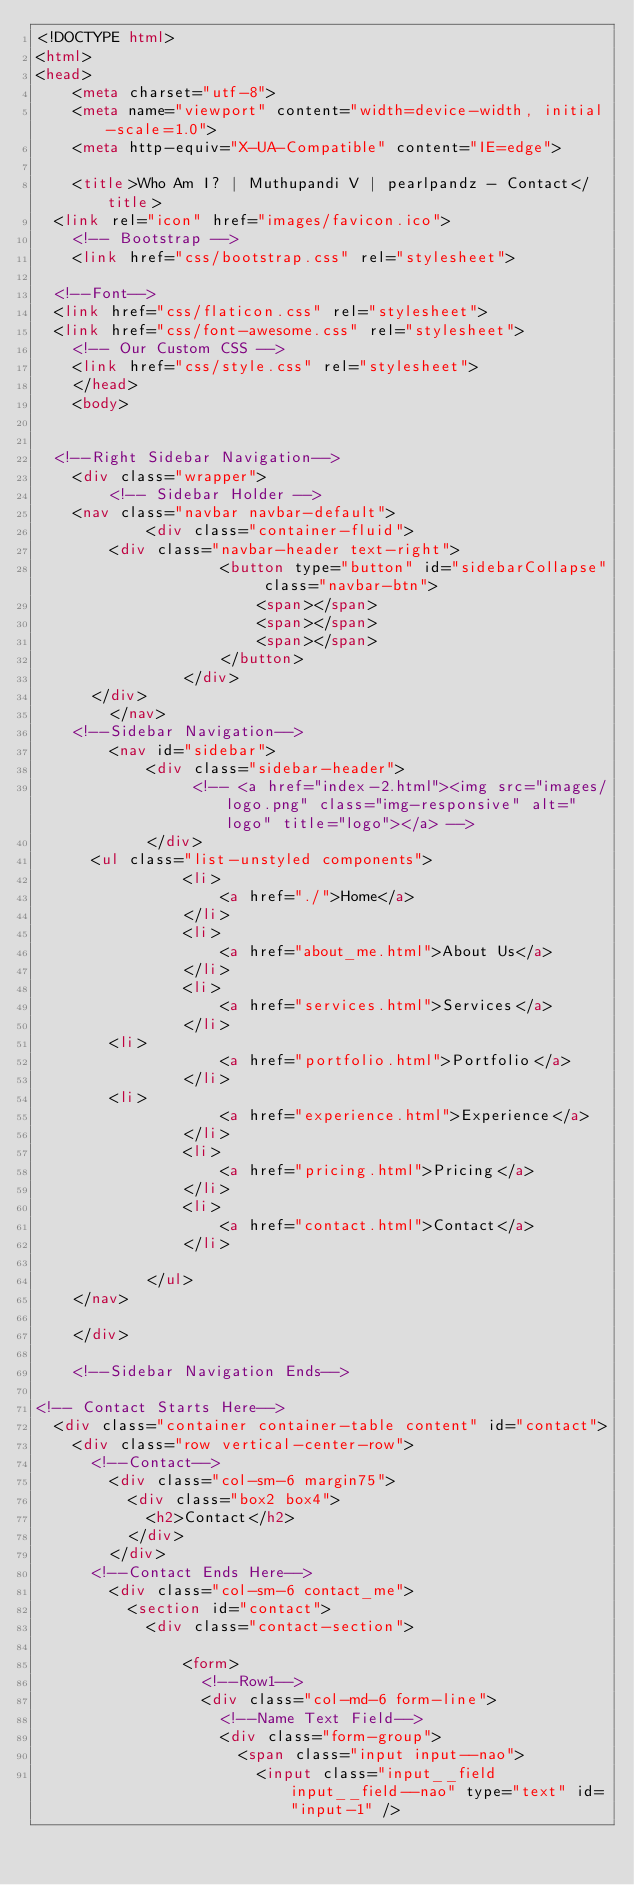<code> <loc_0><loc_0><loc_500><loc_500><_HTML_><!DOCTYPE html>
<html>
<head>
    <meta charset="utf-8">
    <meta name="viewport" content="width=device-width, initial-scale=1.0">
    <meta http-equiv="X-UA-Compatible" content="IE=edge">

    <title>Who Am I? | Muthupandi V | pearlpandz - Contact</title>
	<link rel="icon" href="images/favicon.ico">
    <!-- Bootstrap -->
    <link href="css/bootstrap.css" rel="stylesheet">
	
	<!--Font-->
	<link href="css/flaticon.css" rel="stylesheet">
	<link href="css/font-awesome.css" rel="stylesheet">
    <!-- Our Custom CSS -->
    <link href="css/style.css" rel="stylesheet">
    </head>
    <body>


	<!--Right Sidebar Navigation-->
    <div class="wrapper">
        <!-- Sidebar Holder -->
		<nav class="navbar navbar-default">
            <div class="container-fluid">
				<div class="navbar-header text-right">
                    <button type="button" id="sidebarCollapse" class="navbar-btn">
                        <span></span>
                        <span></span>
                        <span></span>
                    </button>
                </div>
			</div>
        </nav>
		<!--Sidebar Navigation-->
        <nav id="sidebar">
            <div class="sidebar-header">
                 <!-- <a href="index-2.html"><img src="images/logo.png" class="img-responsive" alt="logo" title="logo"></a> -->
            </div>
			<ul class="list-unstyled components">
                <li>
                    <a href="./">Home</a>
                </li>
                <li>
                    <a href="about_me.html">About Us</a>
                </li>
                <li>
                    <a href="services.html">Services</a>
                </li>
				<li>
                    <a href="portfolio.html">Portfolio</a>
                </li>
				<li>
                    <a href="experience.html">Experience</a>
                </li>
                <li>
                    <a href="pricing.html">Pricing</a>
                </li>
                <li>
                    <a href="contact.html">Contact</a>
                </li>
				
            </ul>
		</nav>
			
    </div>

		<!--Sidebar Navigation Ends-->

<!-- Contact Starts Here-->
	<div class="container container-table content" id="contact">
		<div class="row vertical-center-row">
			<!--Contact-->
				<div class="col-sm-6 margin75">
					<div class="box2 box4">
						<h2>Contact</h2>
					</div>
				</div>
			<!--Contact Ends Here-->
				<div class="col-sm-6 contact_me">
					<section id="contact">
						<div class="contact-section">
							
								<form>
									<!--Row1-->
									<div class="col-md-6 form-line">
										<!--Name Text Field-->
										<div class="form-group">
											<span class="input input--nao">
												<input class="input__field input__field--nao" type="text" id="input-1" /></code> 